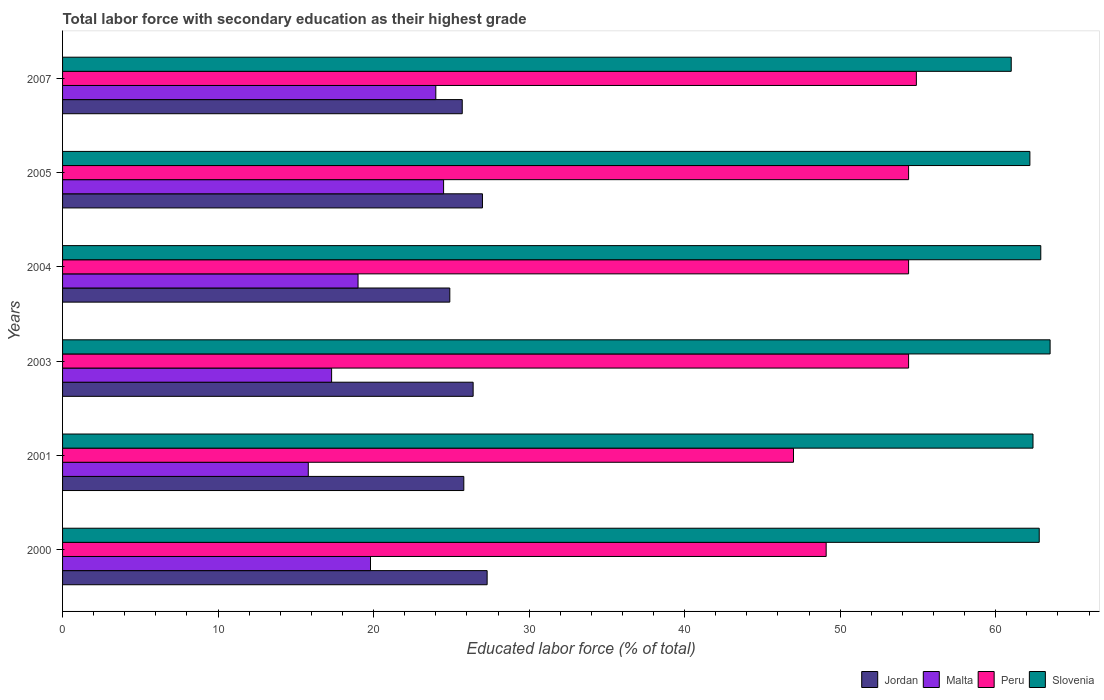How many different coloured bars are there?
Keep it short and to the point. 4. How many groups of bars are there?
Ensure brevity in your answer.  6. Are the number of bars on each tick of the Y-axis equal?
Keep it short and to the point. Yes. What is the label of the 3rd group of bars from the top?
Offer a terse response. 2004. What is the percentage of total labor force with primary education in Jordan in 2005?
Provide a short and direct response. 27. Across all years, what is the maximum percentage of total labor force with primary education in Peru?
Provide a succinct answer. 54.9. Across all years, what is the minimum percentage of total labor force with primary education in Jordan?
Provide a short and direct response. 24.9. In which year was the percentage of total labor force with primary education in Slovenia maximum?
Give a very brief answer. 2003. What is the total percentage of total labor force with primary education in Slovenia in the graph?
Ensure brevity in your answer.  374.8. What is the difference between the percentage of total labor force with primary education in Malta in 2001 and that in 2007?
Provide a succinct answer. -8.2. What is the difference between the percentage of total labor force with primary education in Malta in 2000 and the percentage of total labor force with primary education in Jordan in 2007?
Give a very brief answer. -5.9. What is the average percentage of total labor force with primary education in Slovenia per year?
Your answer should be very brief. 62.47. In the year 2003, what is the difference between the percentage of total labor force with primary education in Slovenia and percentage of total labor force with primary education in Peru?
Offer a terse response. 9.1. What is the ratio of the percentage of total labor force with primary education in Slovenia in 2000 to that in 2005?
Make the answer very short. 1.01. Is the percentage of total labor force with primary education in Slovenia in 2000 less than that in 2004?
Your answer should be compact. Yes. What is the difference between the highest and the lowest percentage of total labor force with primary education in Peru?
Your answer should be very brief. 7.9. Is it the case that in every year, the sum of the percentage of total labor force with primary education in Jordan and percentage of total labor force with primary education in Peru is greater than the sum of percentage of total labor force with primary education in Malta and percentage of total labor force with primary education in Slovenia?
Your answer should be very brief. No. What does the 1st bar from the top in 2007 represents?
Provide a short and direct response. Slovenia. What does the 4th bar from the bottom in 2003 represents?
Your response must be concise. Slovenia. How many years are there in the graph?
Provide a short and direct response. 6. Does the graph contain any zero values?
Offer a terse response. No. Where does the legend appear in the graph?
Your answer should be compact. Bottom right. What is the title of the graph?
Ensure brevity in your answer.  Total labor force with secondary education as their highest grade. What is the label or title of the X-axis?
Give a very brief answer. Educated labor force (% of total). What is the Educated labor force (% of total) in Jordan in 2000?
Your response must be concise. 27.3. What is the Educated labor force (% of total) in Malta in 2000?
Keep it short and to the point. 19.8. What is the Educated labor force (% of total) in Peru in 2000?
Keep it short and to the point. 49.1. What is the Educated labor force (% of total) of Slovenia in 2000?
Ensure brevity in your answer.  62.8. What is the Educated labor force (% of total) in Jordan in 2001?
Your response must be concise. 25.8. What is the Educated labor force (% of total) in Malta in 2001?
Your answer should be compact. 15.8. What is the Educated labor force (% of total) in Slovenia in 2001?
Your answer should be very brief. 62.4. What is the Educated labor force (% of total) in Jordan in 2003?
Provide a short and direct response. 26.4. What is the Educated labor force (% of total) of Malta in 2003?
Offer a terse response. 17.3. What is the Educated labor force (% of total) of Peru in 2003?
Offer a terse response. 54.4. What is the Educated labor force (% of total) of Slovenia in 2003?
Offer a very short reply. 63.5. What is the Educated labor force (% of total) of Jordan in 2004?
Your answer should be compact. 24.9. What is the Educated labor force (% of total) in Peru in 2004?
Your answer should be very brief. 54.4. What is the Educated labor force (% of total) in Slovenia in 2004?
Make the answer very short. 62.9. What is the Educated labor force (% of total) of Jordan in 2005?
Keep it short and to the point. 27. What is the Educated labor force (% of total) of Malta in 2005?
Keep it short and to the point. 24.5. What is the Educated labor force (% of total) in Peru in 2005?
Offer a very short reply. 54.4. What is the Educated labor force (% of total) in Slovenia in 2005?
Ensure brevity in your answer.  62.2. What is the Educated labor force (% of total) in Jordan in 2007?
Offer a very short reply. 25.7. What is the Educated labor force (% of total) in Peru in 2007?
Your answer should be very brief. 54.9. What is the Educated labor force (% of total) of Slovenia in 2007?
Keep it short and to the point. 61. Across all years, what is the maximum Educated labor force (% of total) of Jordan?
Give a very brief answer. 27.3. Across all years, what is the maximum Educated labor force (% of total) in Malta?
Offer a terse response. 24.5. Across all years, what is the maximum Educated labor force (% of total) in Peru?
Offer a terse response. 54.9. Across all years, what is the maximum Educated labor force (% of total) in Slovenia?
Offer a terse response. 63.5. Across all years, what is the minimum Educated labor force (% of total) of Jordan?
Your answer should be compact. 24.9. Across all years, what is the minimum Educated labor force (% of total) in Malta?
Make the answer very short. 15.8. Across all years, what is the minimum Educated labor force (% of total) in Slovenia?
Make the answer very short. 61. What is the total Educated labor force (% of total) in Jordan in the graph?
Your response must be concise. 157.1. What is the total Educated labor force (% of total) of Malta in the graph?
Provide a short and direct response. 120.4. What is the total Educated labor force (% of total) of Peru in the graph?
Give a very brief answer. 314.2. What is the total Educated labor force (% of total) of Slovenia in the graph?
Provide a short and direct response. 374.8. What is the difference between the Educated labor force (% of total) of Jordan in 2000 and that in 2001?
Ensure brevity in your answer.  1.5. What is the difference between the Educated labor force (% of total) of Malta in 2000 and that in 2001?
Ensure brevity in your answer.  4. What is the difference between the Educated labor force (% of total) in Peru in 2000 and that in 2001?
Offer a terse response. 2.1. What is the difference between the Educated labor force (% of total) in Peru in 2000 and that in 2004?
Give a very brief answer. -5.3. What is the difference between the Educated labor force (% of total) in Malta in 2000 and that in 2005?
Ensure brevity in your answer.  -4.7. What is the difference between the Educated labor force (% of total) of Peru in 2000 and that in 2005?
Your response must be concise. -5.3. What is the difference between the Educated labor force (% of total) of Slovenia in 2000 and that in 2005?
Make the answer very short. 0.6. What is the difference between the Educated labor force (% of total) in Peru in 2000 and that in 2007?
Ensure brevity in your answer.  -5.8. What is the difference between the Educated labor force (% of total) in Jordan in 2001 and that in 2003?
Provide a short and direct response. -0.6. What is the difference between the Educated labor force (% of total) in Peru in 2001 and that in 2003?
Make the answer very short. -7.4. What is the difference between the Educated labor force (% of total) of Slovenia in 2001 and that in 2003?
Provide a short and direct response. -1.1. What is the difference between the Educated labor force (% of total) of Peru in 2001 and that in 2004?
Your answer should be very brief. -7.4. What is the difference between the Educated labor force (% of total) of Slovenia in 2001 and that in 2004?
Your response must be concise. -0.5. What is the difference between the Educated labor force (% of total) in Jordan in 2001 and that in 2005?
Give a very brief answer. -1.2. What is the difference between the Educated labor force (% of total) of Slovenia in 2001 and that in 2005?
Make the answer very short. 0.2. What is the difference between the Educated labor force (% of total) in Jordan in 2001 and that in 2007?
Give a very brief answer. 0.1. What is the difference between the Educated labor force (% of total) in Peru in 2001 and that in 2007?
Make the answer very short. -7.9. What is the difference between the Educated labor force (% of total) of Slovenia in 2001 and that in 2007?
Offer a very short reply. 1.4. What is the difference between the Educated labor force (% of total) in Jordan in 2003 and that in 2004?
Provide a succinct answer. 1.5. What is the difference between the Educated labor force (% of total) of Malta in 2003 and that in 2004?
Your response must be concise. -1.7. What is the difference between the Educated labor force (% of total) of Peru in 2003 and that in 2004?
Your answer should be compact. 0. What is the difference between the Educated labor force (% of total) in Jordan in 2003 and that in 2005?
Provide a succinct answer. -0.6. What is the difference between the Educated labor force (% of total) in Slovenia in 2003 and that in 2007?
Give a very brief answer. 2.5. What is the difference between the Educated labor force (% of total) of Jordan in 2004 and that in 2005?
Offer a very short reply. -2.1. What is the difference between the Educated labor force (% of total) of Malta in 2004 and that in 2007?
Your response must be concise. -5. What is the difference between the Educated labor force (% of total) of Peru in 2004 and that in 2007?
Offer a very short reply. -0.5. What is the difference between the Educated labor force (% of total) in Slovenia in 2004 and that in 2007?
Keep it short and to the point. 1.9. What is the difference between the Educated labor force (% of total) of Jordan in 2005 and that in 2007?
Provide a succinct answer. 1.3. What is the difference between the Educated labor force (% of total) of Peru in 2005 and that in 2007?
Provide a short and direct response. -0.5. What is the difference between the Educated labor force (% of total) of Jordan in 2000 and the Educated labor force (% of total) of Malta in 2001?
Ensure brevity in your answer.  11.5. What is the difference between the Educated labor force (% of total) of Jordan in 2000 and the Educated labor force (% of total) of Peru in 2001?
Give a very brief answer. -19.7. What is the difference between the Educated labor force (% of total) in Jordan in 2000 and the Educated labor force (% of total) in Slovenia in 2001?
Offer a terse response. -35.1. What is the difference between the Educated labor force (% of total) of Malta in 2000 and the Educated labor force (% of total) of Peru in 2001?
Ensure brevity in your answer.  -27.2. What is the difference between the Educated labor force (% of total) in Malta in 2000 and the Educated labor force (% of total) in Slovenia in 2001?
Ensure brevity in your answer.  -42.6. What is the difference between the Educated labor force (% of total) of Jordan in 2000 and the Educated labor force (% of total) of Malta in 2003?
Provide a short and direct response. 10. What is the difference between the Educated labor force (% of total) in Jordan in 2000 and the Educated labor force (% of total) in Peru in 2003?
Your answer should be compact. -27.1. What is the difference between the Educated labor force (% of total) in Jordan in 2000 and the Educated labor force (% of total) in Slovenia in 2003?
Provide a short and direct response. -36.2. What is the difference between the Educated labor force (% of total) of Malta in 2000 and the Educated labor force (% of total) of Peru in 2003?
Make the answer very short. -34.6. What is the difference between the Educated labor force (% of total) of Malta in 2000 and the Educated labor force (% of total) of Slovenia in 2003?
Make the answer very short. -43.7. What is the difference between the Educated labor force (% of total) in Peru in 2000 and the Educated labor force (% of total) in Slovenia in 2003?
Provide a succinct answer. -14.4. What is the difference between the Educated labor force (% of total) in Jordan in 2000 and the Educated labor force (% of total) in Peru in 2004?
Your answer should be very brief. -27.1. What is the difference between the Educated labor force (% of total) of Jordan in 2000 and the Educated labor force (% of total) of Slovenia in 2004?
Your answer should be very brief. -35.6. What is the difference between the Educated labor force (% of total) of Malta in 2000 and the Educated labor force (% of total) of Peru in 2004?
Your response must be concise. -34.6. What is the difference between the Educated labor force (% of total) in Malta in 2000 and the Educated labor force (% of total) in Slovenia in 2004?
Your response must be concise. -43.1. What is the difference between the Educated labor force (% of total) of Jordan in 2000 and the Educated labor force (% of total) of Malta in 2005?
Provide a succinct answer. 2.8. What is the difference between the Educated labor force (% of total) of Jordan in 2000 and the Educated labor force (% of total) of Peru in 2005?
Ensure brevity in your answer.  -27.1. What is the difference between the Educated labor force (% of total) of Jordan in 2000 and the Educated labor force (% of total) of Slovenia in 2005?
Provide a short and direct response. -34.9. What is the difference between the Educated labor force (% of total) in Malta in 2000 and the Educated labor force (% of total) in Peru in 2005?
Keep it short and to the point. -34.6. What is the difference between the Educated labor force (% of total) of Malta in 2000 and the Educated labor force (% of total) of Slovenia in 2005?
Keep it short and to the point. -42.4. What is the difference between the Educated labor force (% of total) in Peru in 2000 and the Educated labor force (% of total) in Slovenia in 2005?
Ensure brevity in your answer.  -13.1. What is the difference between the Educated labor force (% of total) of Jordan in 2000 and the Educated labor force (% of total) of Malta in 2007?
Your answer should be compact. 3.3. What is the difference between the Educated labor force (% of total) of Jordan in 2000 and the Educated labor force (% of total) of Peru in 2007?
Your answer should be very brief. -27.6. What is the difference between the Educated labor force (% of total) in Jordan in 2000 and the Educated labor force (% of total) in Slovenia in 2007?
Your answer should be very brief. -33.7. What is the difference between the Educated labor force (% of total) in Malta in 2000 and the Educated labor force (% of total) in Peru in 2007?
Your answer should be compact. -35.1. What is the difference between the Educated labor force (% of total) of Malta in 2000 and the Educated labor force (% of total) of Slovenia in 2007?
Make the answer very short. -41.2. What is the difference between the Educated labor force (% of total) in Peru in 2000 and the Educated labor force (% of total) in Slovenia in 2007?
Your response must be concise. -11.9. What is the difference between the Educated labor force (% of total) of Jordan in 2001 and the Educated labor force (% of total) of Malta in 2003?
Your answer should be very brief. 8.5. What is the difference between the Educated labor force (% of total) in Jordan in 2001 and the Educated labor force (% of total) in Peru in 2003?
Give a very brief answer. -28.6. What is the difference between the Educated labor force (% of total) of Jordan in 2001 and the Educated labor force (% of total) of Slovenia in 2003?
Your answer should be very brief. -37.7. What is the difference between the Educated labor force (% of total) in Malta in 2001 and the Educated labor force (% of total) in Peru in 2003?
Your answer should be very brief. -38.6. What is the difference between the Educated labor force (% of total) in Malta in 2001 and the Educated labor force (% of total) in Slovenia in 2003?
Your response must be concise. -47.7. What is the difference between the Educated labor force (% of total) of Peru in 2001 and the Educated labor force (% of total) of Slovenia in 2003?
Offer a very short reply. -16.5. What is the difference between the Educated labor force (% of total) of Jordan in 2001 and the Educated labor force (% of total) of Peru in 2004?
Make the answer very short. -28.6. What is the difference between the Educated labor force (% of total) of Jordan in 2001 and the Educated labor force (% of total) of Slovenia in 2004?
Your response must be concise. -37.1. What is the difference between the Educated labor force (% of total) in Malta in 2001 and the Educated labor force (% of total) in Peru in 2004?
Make the answer very short. -38.6. What is the difference between the Educated labor force (% of total) in Malta in 2001 and the Educated labor force (% of total) in Slovenia in 2004?
Ensure brevity in your answer.  -47.1. What is the difference between the Educated labor force (% of total) of Peru in 2001 and the Educated labor force (% of total) of Slovenia in 2004?
Offer a very short reply. -15.9. What is the difference between the Educated labor force (% of total) of Jordan in 2001 and the Educated labor force (% of total) of Peru in 2005?
Offer a very short reply. -28.6. What is the difference between the Educated labor force (% of total) of Jordan in 2001 and the Educated labor force (% of total) of Slovenia in 2005?
Offer a very short reply. -36.4. What is the difference between the Educated labor force (% of total) in Malta in 2001 and the Educated labor force (% of total) in Peru in 2005?
Your response must be concise. -38.6. What is the difference between the Educated labor force (% of total) in Malta in 2001 and the Educated labor force (% of total) in Slovenia in 2005?
Provide a short and direct response. -46.4. What is the difference between the Educated labor force (% of total) in Peru in 2001 and the Educated labor force (% of total) in Slovenia in 2005?
Your response must be concise. -15.2. What is the difference between the Educated labor force (% of total) of Jordan in 2001 and the Educated labor force (% of total) of Peru in 2007?
Provide a succinct answer. -29.1. What is the difference between the Educated labor force (% of total) in Jordan in 2001 and the Educated labor force (% of total) in Slovenia in 2007?
Provide a succinct answer. -35.2. What is the difference between the Educated labor force (% of total) of Malta in 2001 and the Educated labor force (% of total) of Peru in 2007?
Provide a short and direct response. -39.1. What is the difference between the Educated labor force (% of total) of Malta in 2001 and the Educated labor force (% of total) of Slovenia in 2007?
Give a very brief answer. -45.2. What is the difference between the Educated labor force (% of total) in Jordan in 2003 and the Educated labor force (% of total) in Malta in 2004?
Provide a succinct answer. 7.4. What is the difference between the Educated labor force (% of total) of Jordan in 2003 and the Educated labor force (% of total) of Slovenia in 2004?
Make the answer very short. -36.5. What is the difference between the Educated labor force (% of total) of Malta in 2003 and the Educated labor force (% of total) of Peru in 2004?
Ensure brevity in your answer.  -37.1. What is the difference between the Educated labor force (% of total) in Malta in 2003 and the Educated labor force (% of total) in Slovenia in 2004?
Provide a succinct answer. -45.6. What is the difference between the Educated labor force (% of total) in Jordan in 2003 and the Educated labor force (% of total) in Malta in 2005?
Provide a succinct answer. 1.9. What is the difference between the Educated labor force (% of total) of Jordan in 2003 and the Educated labor force (% of total) of Slovenia in 2005?
Your answer should be compact. -35.8. What is the difference between the Educated labor force (% of total) in Malta in 2003 and the Educated labor force (% of total) in Peru in 2005?
Give a very brief answer. -37.1. What is the difference between the Educated labor force (% of total) in Malta in 2003 and the Educated labor force (% of total) in Slovenia in 2005?
Provide a short and direct response. -44.9. What is the difference between the Educated labor force (% of total) of Peru in 2003 and the Educated labor force (% of total) of Slovenia in 2005?
Make the answer very short. -7.8. What is the difference between the Educated labor force (% of total) of Jordan in 2003 and the Educated labor force (% of total) of Malta in 2007?
Provide a succinct answer. 2.4. What is the difference between the Educated labor force (% of total) in Jordan in 2003 and the Educated labor force (% of total) in Peru in 2007?
Your response must be concise. -28.5. What is the difference between the Educated labor force (% of total) in Jordan in 2003 and the Educated labor force (% of total) in Slovenia in 2007?
Provide a succinct answer. -34.6. What is the difference between the Educated labor force (% of total) of Malta in 2003 and the Educated labor force (% of total) of Peru in 2007?
Ensure brevity in your answer.  -37.6. What is the difference between the Educated labor force (% of total) of Malta in 2003 and the Educated labor force (% of total) of Slovenia in 2007?
Keep it short and to the point. -43.7. What is the difference between the Educated labor force (% of total) in Peru in 2003 and the Educated labor force (% of total) in Slovenia in 2007?
Your answer should be very brief. -6.6. What is the difference between the Educated labor force (% of total) of Jordan in 2004 and the Educated labor force (% of total) of Malta in 2005?
Ensure brevity in your answer.  0.4. What is the difference between the Educated labor force (% of total) of Jordan in 2004 and the Educated labor force (% of total) of Peru in 2005?
Keep it short and to the point. -29.5. What is the difference between the Educated labor force (% of total) of Jordan in 2004 and the Educated labor force (% of total) of Slovenia in 2005?
Offer a very short reply. -37.3. What is the difference between the Educated labor force (% of total) of Malta in 2004 and the Educated labor force (% of total) of Peru in 2005?
Ensure brevity in your answer.  -35.4. What is the difference between the Educated labor force (% of total) of Malta in 2004 and the Educated labor force (% of total) of Slovenia in 2005?
Provide a succinct answer. -43.2. What is the difference between the Educated labor force (% of total) in Jordan in 2004 and the Educated labor force (% of total) in Slovenia in 2007?
Give a very brief answer. -36.1. What is the difference between the Educated labor force (% of total) of Malta in 2004 and the Educated labor force (% of total) of Peru in 2007?
Make the answer very short. -35.9. What is the difference between the Educated labor force (% of total) of Malta in 2004 and the Educated labor force (% of total) of Slovenia in 2007?
Your answer should be very brief. -42. What is the difference between the Educated labor force (% of total) of Peru in 2004 and the Educated labor force (% of total) of Slovenia in 2007?
Your response must be concise. -6.6. What is the difference between the Educated labor force (% of total) of Jordan in 2005 and the Educated labor force (% of total) of Peru in 2007?
Your response must be concise. -27.9. What is the difference between the Educated labor force (% of total) in Jordan in 2005 and the Educated labor force (% of total) in Slovenia in 2007?
Offer a very short reply. -34. What is the difference between the Educated labor force (% of total) of Malta in 2005 and the Educated labor force (% of total) of Peru in 2007?
Offer a very short reply. -30.4. What is the difference between the Educated labor force (% of total) of Malta in 2005 and the Educated labor force (% of total) of Slovenia in 2007?
Keep it short and to the point. -36.5. What is the average Educated labor force (% of total) in Jordan per year?
Your answer should be very brief. 26.18. What is the average Educated labor force (% of total) in Malta per year?
Ensure brevity in your answer.  20.07. What is the average Educated labor force (% of total) in Peru per year?
Make the answer very short. 52.37. What is the average Educated labor force (% of total) of Slovenia per year?
Provide a short and direct response. 62.47. In the year 2000, what is the difference between the Educated labor force (% of total) of Jordan and Educated labor force (% of total) of Malta?
Make the answer very short. 7.5. In the year 2000, what is the difference between the Educated labor force (% of total) in Jordan and Educated labor force (% of total) in Peru?
Give a very brief answer. -21.8. In the year 2000, what is the difference between the Educated labor force (% of total) of Jordan and Educated labor force (% of total) of Slovenia?
Offer a terse response. -35.5. In the year 2000, what is the difference between the Educated labor force (% of total) in Malta and Educated labor force (% of total) in Peru?
Your answer should be compact. -29.3. In the year 2000, what is the difference between the Educated labor force (% of total) of Malta and Educated labor force (% of total) of Slovenia?
Offer a very short reply. -43. In the year 2000, what is the difference between the Educated labor force (% of total) in Peru and Educated labor force (% of total) in Slovenia?
Your response must be concise. -13.7. In the year 2001, what is the difference between the Educated labor force (% of total) in Jordan and Educated labor force (% of total) in Peru?
Offer a terse response. -21.2. In the year 2001, what is the difference between the Educated labor force (% of total) in Jordan and Educated labor force (% of total) in Slovenia?
Your answer should be compact. -36.6. In the year 2001, what is the difference between the Educated labor force (% of total) in Malta and Educated labor force (% of total) in Peru?
Make the answer very short. -31.2. In the year 2001, what is the difference between the Educated labor force (% of total) in Malta and Educated labor force (% of total) in Slovenia?
Give a very brief answer. -46.6. In the year 2001, what is the difference between the Educated labor force (% of total) of Peru and Educated labor force (% of total) of Slovenia?
Your answer should be very brief. -15.4. In the year 2003, what is the difference between the Educated labor force (% of total) in Jordan and Educated labor force (% of total) in Malta?
Provide a short and direct response. 9.1. In the year 2003, what is the difference between the Educated labor force (% of total) of Jordan and Educated labor force (% of total) of Slovenia?
Make the answer very short. -37.1. In the year 2003, what is the difference between the Educated labor force (% of total) in Malta and Educated labor force (% of total) in Peru?
Offer a terse response. -37.1. In the year 2003, what is the difference between the Educated labor force (% of total) in Malta and Educated labor force (% of total) in Slovenia?
Provide a succinct answer. -46.2. In the year 2004, what is the difference between the Educated labor force (% of total) of Jordan and Educated labor force (% of total) of Malta?
Provide a succinct answer. 5.9. In the year 2004, what is the difference between the Educated labor force (% of total) of Jordan and Educated labor force (% of total) of Peru?
Your answer should be very brief. -29.5. In the year 2004, what is the difference between the Educated labor force (% of total) of Jordan and Educated labor force (% of total) of Slovenia?
Give a very brief answer. -38. In the year 2004, what is the difference between the Educated labor force (% of total) of Malta and Educated labor force (% of total) of Peru?
Provide a succinct answer. -35.4. In the year 2004, what is the difference between the Educated labor force (% of total) of Malta and Educated labor force (% of total) of Slovenia?
Give a very brief answer. -43.9. In the year 2004, what is the difference between the Educated labor force (% of total) in Peru and Educated labor force (% of total) in Slovenia?
Provide a succinct answer. -8.5. In the year 2005, what is the difference between the Educated labor force (% of total) of Jordan and Educated labor force (% of total) of Malta?
Your answer should be compact. 2.5. In the year 2005, what is the difference between the Educated labor force (% of total) of Jordan and Educated labor force (% of total) of Peru?
Your response must be concise. -27.4. In the year 2005, what is the difference between the Educated labor force (% of total) in Jordan and Educated labor force (% of total) in Slovenia?
Ensure brevity in your answer.  -35.2. In the year 2005, what is the difference between the Educated labor force (% of total) of Malta and Educated labor force (% of total) of Peru?
Your response must be concise. -29.9. In the year 2005, what is the difference between the Educated labor force (% of total) of Malta and Educated labor force (% of total) of Slovenia?
Keep it short and to the point. -37.7. In the year 2005, what is the difference between the Educated labor force (% of total) in Peru and Educated labor force (% of total) in Slovenia?
Your answer should be very brief. -7.8. In the year 2007, what is the difference between the Educated labor force (% of total) in Jordan and Educated labor force (% of total) in Malta?
Your answer should be compact. 1.7. In the year 2007, what is the difference between the Educated labor force (% of total) of Jordan and Educated labor force (% of total) of Peru?
Keep it short and to the point. -29.2. In the year 2007, what is the difference between the Educated labor force (% of total) in Jordan and Educated labor force (% of total) in Slovenia?
Your answer should be compact. -35.3. In the year 2007, what is the difference between the Educated labor force (% of total) of Malta and Educated labor force (% of total) of Peru?
Offer a terse response. -30.9. In the year 2007, what is the difference between the Educated labor force (% of total) of Malta and Educated labor force (% of total) of Slovenia?
Give a very brief answer. -37. In the year 2007, what is the difference between the Educated labor force (% of total) of Peru and Educated labor force (% of total) of Slovenia?
Give a very brief answer. -6.1. What is the ratio of the Educated labor force (% of total) in Jordan in 2000 to that in 2001?
Offer a terse response. 1.06. What is the ratio of the Educated labor force (% of total) in Malta in 2000 to that in 2001?
Your response must be concise. 1.25. What is the ratio of the Educated labor force (% of total) of Peru in 2000 to that in 2001?
Give a very brief answer. 1.04. What is the ratio of the Educated labor force (% of total) of Slovenia in 2000 to that in 2001?
Ensure brevity in your answer.  1.01. What is the ratio of the Educated labor force (% of total) of Jordan in 2000 to that in 2003?
Offer a terse response. 1.03. What is the ratio of the Educated labor force (% of total) in Malta in 2000 to that in 2003?
Ensure brevity in your answer.  1.14. What is the ratio of the Educated labor force (% of total) in Peru in 2000 to that in 2003?
Provide a succinct answer. 0.9. What is the ratio of the Educated labor force (% of total) in Slovenia in 2000 to that in 2003?
Your answer should be compact. 0.99. What is the ratio of the Educated labor force (% of total) in Jordan in 2000 to that in 2004?
Ensure brevity in your answer.  1.1. What is the ratio of the Educated labor force (% of total) of Malta in 2000 to that in 2004?
Your response must be concise. 1.04. What is the ratio of the Educated labor force (% of total) of Peru in 2000 to that in 2004?
Make the answer very short. 0.9. What is the ratio of the Educated labor force (% of total) of Jordan in 2000 to that in 2005?
Offer a very short reply. 1.01. What is the ratio of the Educated labor force (% of total) in Malta in 2000 to that in 2005?
Your response must be concise. 0.81. What is the ratio of the Educated labor force (% of total) in Peru in 2000 to that in 2005?
Ensure brevity in your answer.  0.9. What is the ratio of the Educated labor force (% of total) of Slovenia in 2000 to that in 2005?
Your answer should be compact. 1.01. What is the ratio of the Educated labor force (% of total) in Jordan in 2000 to that in 2007?
Offer a very short reply. 1.06. What is the ratio of the Educated labor force (% of total) in Malta in 2000 to that in 2007?
Ensure brevity in your answer.  0.82. What is the ratio of the Educated labor force (% of total) in Peru in 2000 to that in 2007?
Your response must be concise. 0.89. What is the ratio of the Educated labor force (% of total) in Slovenia in 2000 to that in 2007?
Offer a terse response. 1.03. What is the ratio of the Educated labor force (% of total) in Jordan in 2001 to that in 2003?
Provide a short and direct response. 0.98. What is the ratio of the Educated labor force (% of total) of Malta in 2001 to that in 2003?
Offer a very short reply. 0.91. What is the ratio of the Educated labor force (% of total) in Peru in 2001 to that in 2003?
Your answer should be very brief. 0.86. What is the ratio of the Educated labor force (% of total) in Slovenia in 2001 to that in 2003?
Offer a very short reply. 0.98. What is the ratio of the Educated labor force (% of total) in Jordan in 2001 to that in 2004?
Provide a succinct answer. 1.04. What is the ratio of the Educated labor force (% of total) in Malta in 2001 to that in 2004?
Offer a terse response. 0.83. What is the ratio of the Educated labor force (% of total) of Peru in 2001 to that in 2004?
Your answer should be very brief. 0.86. What is the ratio of the Educated labor force (% of total) of Slovenia in 2001 to that in 2004?
Make the answer very short. 0.99. What is the ratio of the Educated labor force (% of total) in Jordan in 2001 to that in 2005?
Your answer should be compact. 0.96. What is the ratio of the Educated labor force (% of total) in Malta in 2001 to that in 2005?
Offer a terse response. 0.64. What is the ratio of the Educated labor force (% of total) of Peru in 2001 to that in 2005?
Your response must be concise. 0.86. What is the ratio of the Educated labor force (% of total) in Jordan in 2001 to that in 2007?
Provide a succinct answer. 1. What is the ratio of the Educated labor force (% of total) of Malta in 2001 to that in 2007?
Your response must be concise. 0.66. What is the ratio of the Educated labor force (% of total) of Peru in 2001 to that in 2007?
Give a very brief answer. 0.86. What is the ratio of the Educated labor force (% of total) in Slovenia in 2001 to that in 2007?
Your answer should be very brief. 1.02. What is the ratio of the Educated labor force (% of total) of Jordan in 2003 to that in 2004?
Keep it short and to the point. 1.06. What is the ratio of the Educated labor force (% of total) of Malta in 2003 to that in 2004?
Offer a very short reply. 0.91. What is the ratio of the Educated labor force (% of total) in Slovenia in 2003 to that in 2004?
Provide a succinct answer. 1.01. What is the ratio of the Educated labor force (% of total) in Jordan in 2003 to that in 2005?
Provide a succinct answer. 0.98. What is the ratio of the Educated labor force (% of total) of Malta in 2003 to that in 2005?
Offer a very short reply. 0.71. What is the ratio of the Educated labor force (% of total) of Slovenia in 2003 to that in 2005?
Your response must be concise. 1.02. What is the ratio of the Educated labor force (% of total) of Jordan in 2003 to that in 2007?
Your response must be concise. 1.03. What is the ratio of the Educated labor force (% of total) in Malta in 2003 to that in 2007?
Provide a succinct answer. 0.72. What is the ratio of the Educated labor force (% of total) of Peru in 2003 to that in 2007?
Offer a terse response. 0.99. What is the ratio of the Educated labor force (% of total) in Slovenia in 2003 to that in 2007?
Ensure brevity in your answer.  1.04. What is the ratio of the Educated labor force (% of total) of Jordan in 2004 to that in 2005?
Offer a very short reply. 0.92. What is the ratio of the Educated labor force (% of total) of Malta in 2004 to that in 2005?
Your response must be concise. 0.78. What is the ratio of the Educated labor force (% of total) of Slovenia in 2004 to that in 2005?
Make the answer very short. 1.01. What is the ratio of the Educated labor force (% of total) of Jordan in 2004 to that in 2007?
Provide a short and direct response. 0.97. What is the ratio of the Educated labor force (% of total) of Malta in 2004 to that in 2007?
Ensure brevity in your answer.  0.79. What is the ratio of the Educated labor force (% of total) in Peru in 2004 to that in 2007?
Make the answer very short. 0.99. What is the ratio of the Educated labor force (% of total) of Slovenia in 2004 to that in 2007?
Offer a very short reply. 1.03. What is the ratio of the Educated labor force (% of total) in Jordan in 2005 to that in 2007?
Your answer should be compact. 1.05. What is the ratio of the Educated labor force (% of total) of Malta in 2005 to that in 2007?
Offer a very short reply. 1.02. What is the ratio of the Educated labor force (% of total) of Peru in 2005 to that in 2007?
Your response must be concise. 0.99. What is the ratio of the Educated labor force (% of total) of Slovenia in 2005 to that in 2007?
Offer a very short reply. 1.02. What is the difference between the highest and the second highest Educated labor force (% of total) in Peru?
Your response must be concise. 0.5. What is the difference between the highest and the lowest Educated labor force (% of total) of Jordan?
Ensure brevity in your answer.  2.4. What is the difference between the highest and the lowest Educated labor force (% of total) of Malta?
Offer a very short reply. 8.7. 